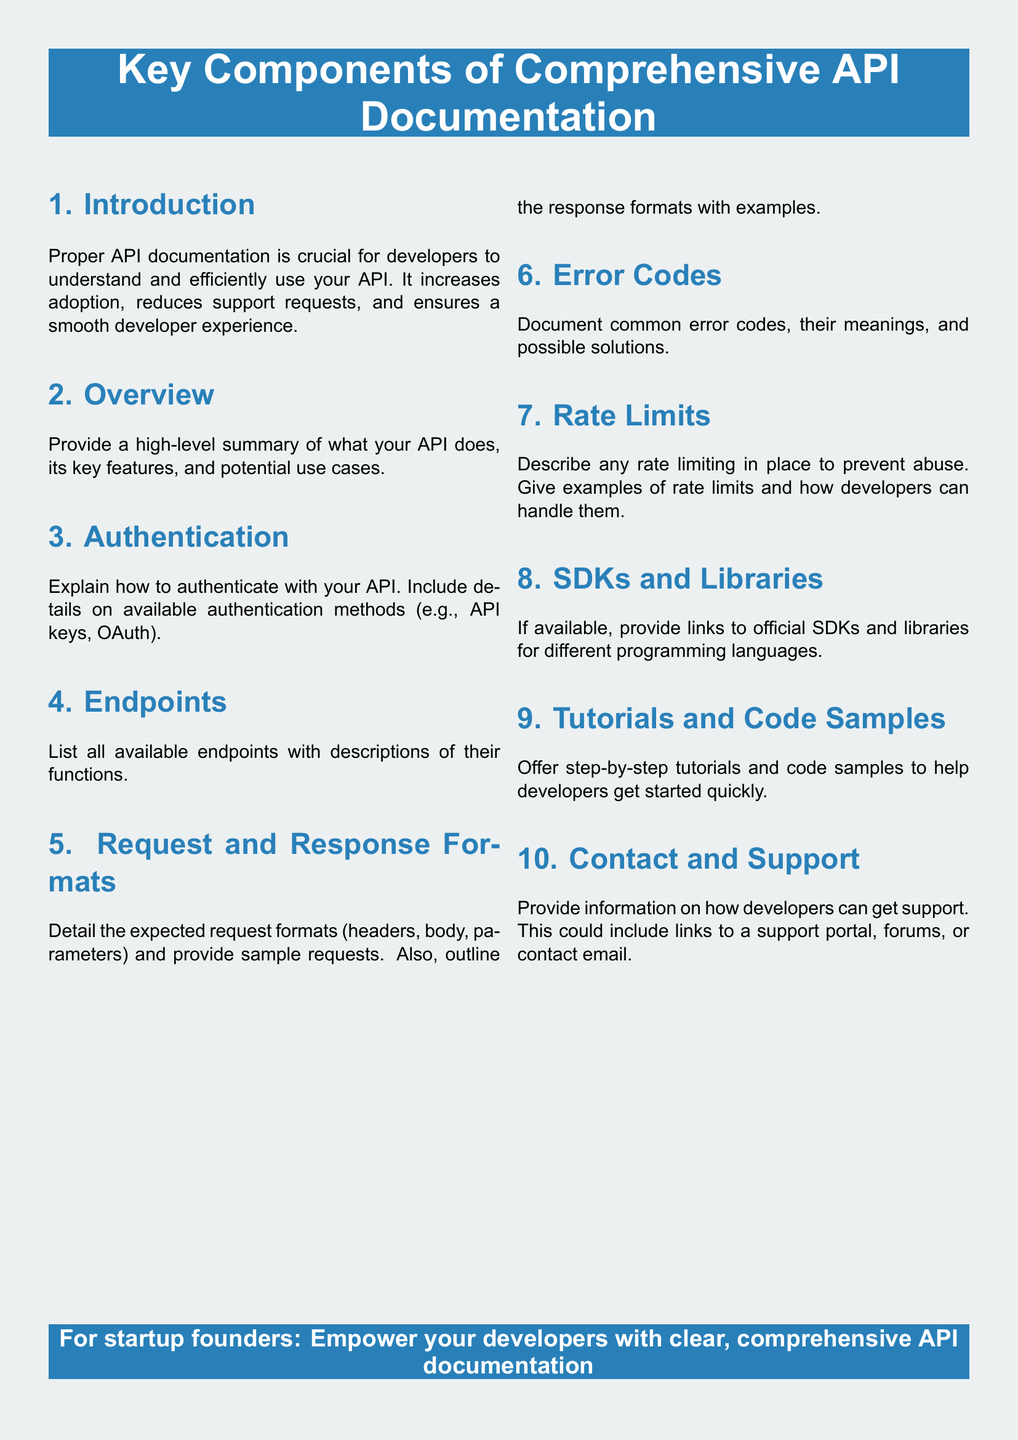What is the main purpose of API documentation? The main purpose of API documentation is to help developers understand and efficiently use the API, increasing adoption and reducing support requests.
Answer: To help developers understand and efficiently use the API What is included in the "Endpoints" section? The "Endpoints" section lists all available endpoints with descriptions of their functions.
Answer: All available endpoints with descriptions of their functions What does the "Error Codes" section document? The "Error Codes" section documents common error codes, their meanings, and possible solutions.
Answer: Common error codes, their meanings, and possible solutions What are SDKs and Libraries mentioned for? SDKs and Libraries are provided to offer links to official SDKs and libraries for different programming languages.
Answer: Links to official SDKs and libraries for different programming languages How many sections are there in the API documentation flyer? The flyer contains ten sections, each addressing a key component of API documentation.
Answer: Ten sections What kind of information can developers find under "Contact and Support"? Developers can find information on how to get support, including links to a support portal, forums, or contact email.
Answer: How to get support, including links to a support portal, forums, or contact email What is the overall theme color of the document? The overall theme color of the document is startup blue.
Answer: Startup blue 